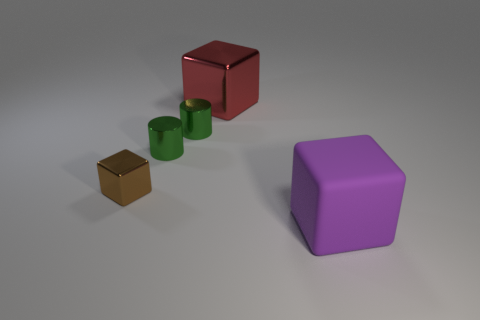Subtract all tiny brown blocks. How many blocks are left? 2 Subtract all purple blocks. How many blocks are left? 2 Subtract 1 cylinders. How many cylinders are left? 1 Add 3 tiny red metallic cylinders. How many objects exist? 8 Subtract all green cylinders. How many yellow cubes are left? 0 Subtract all blocks. How many objects are left? 2 Subtract all purple objects. Subtract all big rubber balls. How many objects are left? 4 Add 2 large rubber blocks. How many large rubber blocks are left? 3 Add 4 tiny objects. How many tiny objects exist? 7 Subtract 0 brown cylinders. How many objects are left? 5 